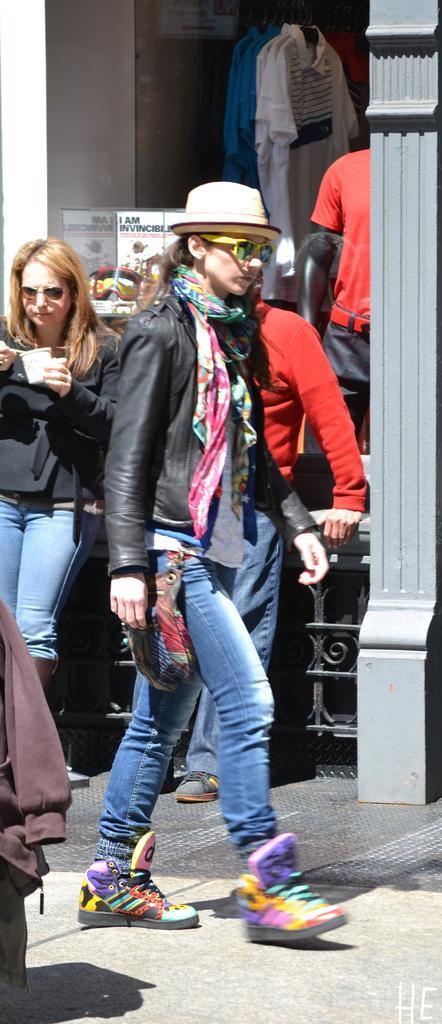Can you describe this image briefly? In this image, we can see three people. Few are standing and walking on the walkway. Here a woman is holding some objects. Background we can see store, clothes, banners. Here there is a pillars and railing. Right side bottom corner, we can see a watermark. 